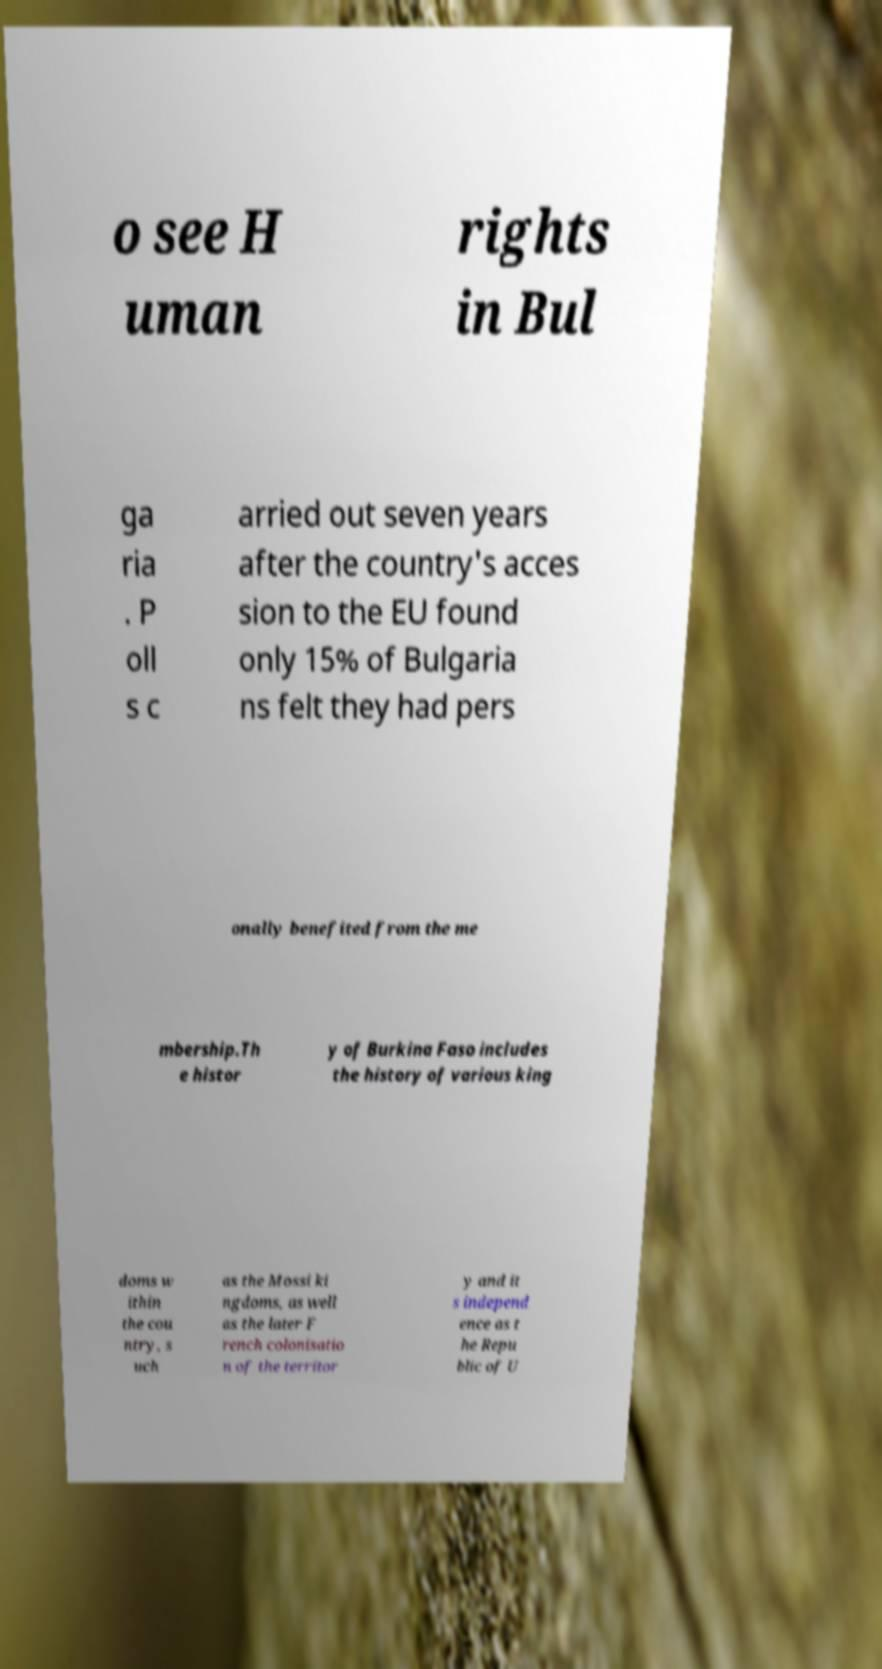Please read and relay the text visible in this image. What does it say? o see H uman rights in Bul ga ria . P oll s c arried out seven years after the country's acces sion to the EU found only 15% of Bulgaria ns felt they had pers onally benefited from the me mbership.Th e histor y of Burkina Faso includes the history of various king doms w ithin the cou ntry, s uch as the Mossi ki ngdoms, as well as the later F rench colonisatio n of the territor y and it s independ ence as t he Repu blic of U 